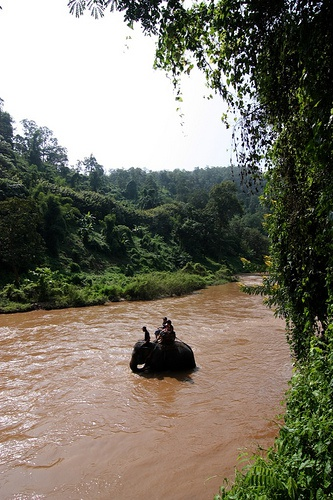Describe the objects in this image and their specific colors. I can see elephant in white, black, gray, and darkgray tones, people in white, black, maroon, and gray tones, people in white, black, darkgray, gray, and maroon tones, and people in white, black, and gray tones in this image. 